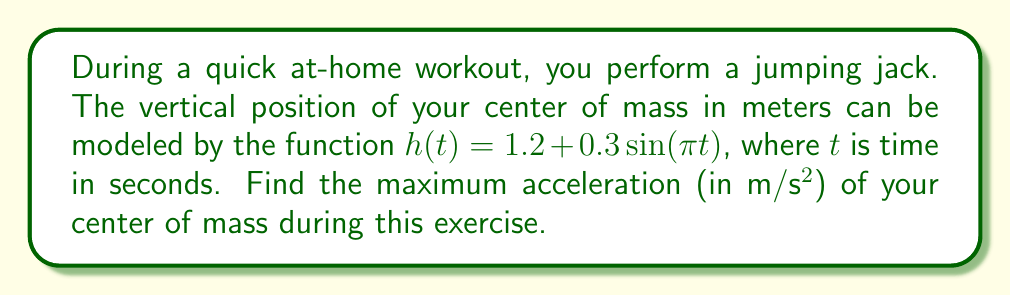Help me with this question. To find the maximum acceleration, we need to follow these steps:

1) The acceleration is the second derivative of the position function. So, we need to differentiate $h(t)$ twice.

2) First derivative (velocity):
   $$\frac{dh}{dt} = h'(t) = 0.3\pi \cos(\pi t)$$

3) Second derivative (acceleration):
   $$\frac{d^2h}{dt^2} = h''(t) = -0.3\pi^2 \sin(\pi t)$$

4) The maximum absolute value of $\sin(\pi t)$ is 1, which occurs when $\sin(\pi t) = \pm 1$.

5) Therefore, the maximum acceleration in magnitude is:
   $$|a_{max}| = 0.3\pi^2 \approx 2.96 \text{ m/s²}$$

6) Round to two decimal places for the final answer.
Answer: $2.96 \text{ m/s²}$ 